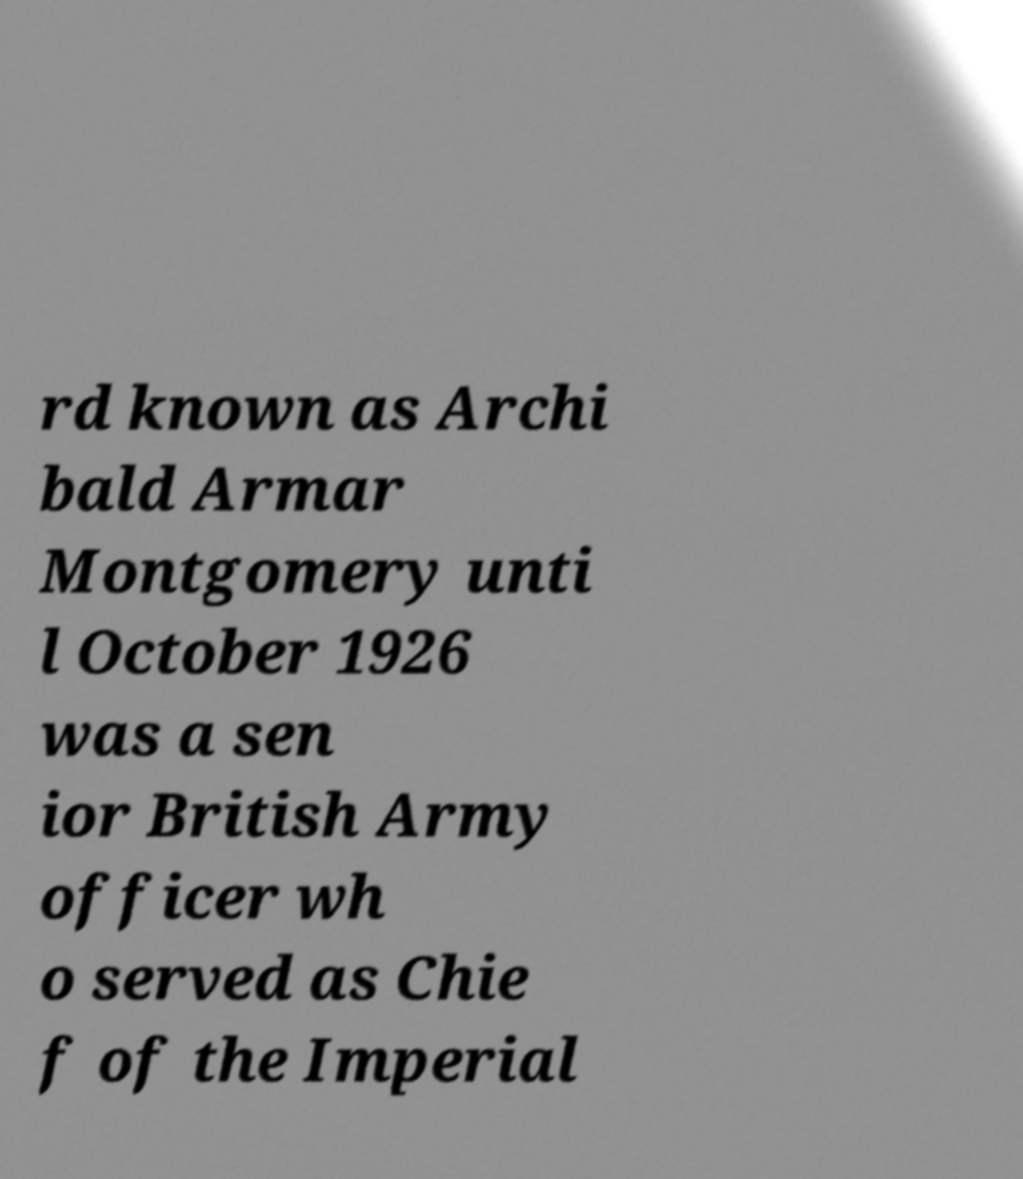Could you assist in decoding the text presented in this image and type it out clearly? rd known as Archi bald Armar Montgomery unti l October 1926 was a sen ior British Army officer wh o served as Chie f of the Imperial 